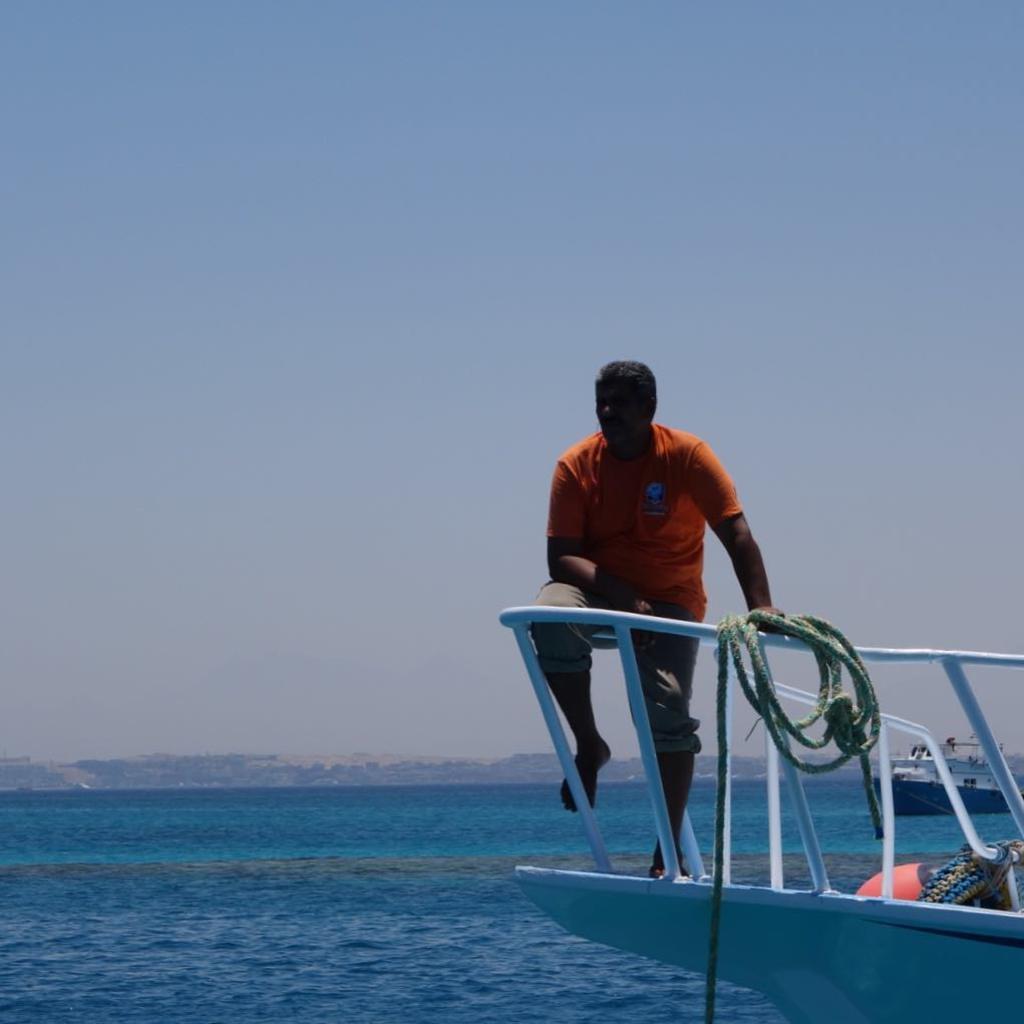Could you give a brief overview of what you see in this image? This is the man sitting on an iron rod. This looks like a rope, which is hanging. I think this is the boat. These are the water flowing. In the background, I can see a ship on the water. 